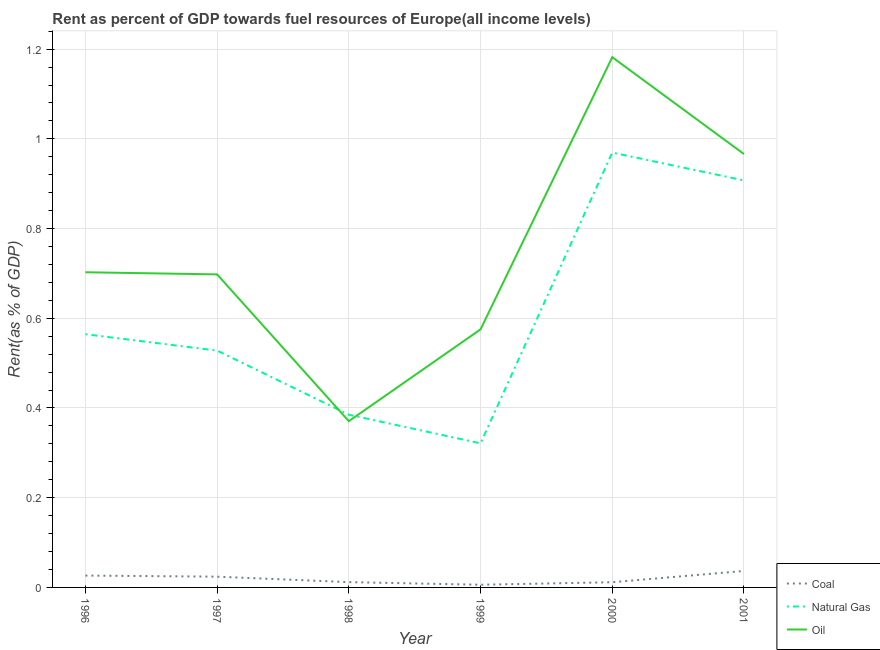Does the line corresponding to rent towards oil intersect with the line corresponding to rent towards natural gas?
Your answer should be compact. Yes. Is the number of lines equal to the number of legend labels?
Offer a very short reply. Yes. What is the rent towards natural gas in 1997?
Provide a short and direct response. 0.53. Across all years, what is the maximum rent towards coal?
Your answer should be very brief. 0.04. Across all years, what is the minimum rent towards coal?
Ensure brevity in your answer.  0.01. In which year was the rent towards natural gas minimum?
Your answer should be compact. 1999. What is the total rent towards oil in the graph?
Make the answer very short. 4.49. What is the difference between the rent towards oil in 1998 and that in 2000?
Your answer should be compact. -0.81. What is the difference between the rent towards oil in 1997 and the rent towards natural gas in 1998?
Provide a short and direct response. 0.31. What is the average rent towards oil per year?
Your answer should be compact. 0.75. In the year 2001, what is the difference between the rent towards oil and rent towards natural gas?
Give a very brief answer. 0.06. What is the ratio of the rent towards oil in 1999 to that in 2001?
Ensure brevity in your answer.  0.6. What is the difference between the highest and the second highest rent towards natural gas?
Offer a very short reply. 0.06. What is the difference between the highest and the lowest rent towards coal?
Give a very brief answer. 0.03. In how many years, is the rent towards coal greater than the average rent towards coal taken over all years?
Give a very brief answer. 3. Is the sum of the rent towards natural gas in 1999 and 2001 greater than the maximum rent towards oil across all years?
Your answer should be very brief. Yes. Is it the case that in every year, the sum of the rent towards coal and rent towards natural gas is greater than the rent towards oil?
Offer a very short reply. No. Does the rent towards natural gas monotonically increase over the years?
Keep it short and to the point. No. Is the rent towards natural gas strictly less than the rent towards oil over the years?
Your answer should be compact. No. How many years are there in the graph?
Keep it short and to the point. 6. What is the difference between two consecutive major ticks on the Y-axis?
Offer a terse response. 0.2. Does the graph contain grids?
Your answer should be very brief. Yes. How many legend labels are there?
Provide a succinct answer. 3. What is the title of the graph?
Provide a succinct answer. Rent as percent of GDP towards fuel resources of Europe(all income levels). Does "Industry" appear as one of the legend labels in the graph?
Offer a very short reply. No. What is the label or title of the X-axis?
Provide a succinct answer. Year. What is the label or title of the Y-axis?
Provide a succinct answer. Rent(as % of GDP). What is the Rent(as % of GDP) in Coal in 1996?
Your answer should be very brief. 0.03. What is the Rent(as % of GDP) of Natural Gas in 1996?
Give a very brief answer. 0.56. What is the Rent(as % of GDP) in Oil in 1996?
Give a very brief answer. 0.7. What is the Rent(as % of GDP) in Coal in 1997?
Keep it short and to the point. 0.02. What is the Rent(as % of GDP) of Natural Gas in 1997?
Give a very brief answer. 0.53. What is the Rent(as % of GDP) in Oil in 1997?
Keep it short and to the point. 0.7. What is the Rent(as % of GDP) of Coal in 1998?
Offer a very short reply. 0.01. What is the Rent(as % of GDP) in Natural Gas in 1998?
Offer a very short reply. 0.38. What is the Rent(as % of GDP) in Oil in 1998?
Ensure brevity in your answer.  0.37. What is the Rent(as % of GDP) in Coal in 1999?
Provide a succinct answer. 0.01. What is the Rent(as % of GDP) in Natural Gas in 1999?
Your answer should be compact. 0.32. What is the Rent(as % of GDP) in Oil in 1999?
Provide a succinct answer. 0.58. What is the Rent(as % of GDP) in Coal in 2000?
Provide a succinct answer. 0.01. What is the Rent(as % of GDP) in Natural Gas in 2000?
Your response must be concise. 0.97. What is the Rent(as % of GDP) in Oil in 2000?
Keep it short and to the point. 1.18. What is the Rent(as % of GDP) in Coal in 2001?
Your response must be concise. 0.04. What is the Rent(as % of GDP) in Natural Gas in 2001?
Offer a terse response. 0.91. What is the Rent(as % of GDP) in Oil in 2001?
Keep it short and to the point. 0.97. Across all years, what is the maximum Rent(as % of GDP) of Coal?
Keep it short and to the point. 0.04. Across all years, what is the maximum Rent(as % of GDP) in Natural Gas?
Offer a very short reply. 0.97. Across all years, what is the maximum Rent(as % of GDP) in Oil?
Your answer should be very brief. 1.18. Across all years, what is the minimum Rent(as % of GDP) in Coal?
Provide a short and direct response. 0.01. Across all years, what is the minimum Rent(as % of GDP) in Natural Gas?
Make the answer very short. 0.32. Across all years, what is the minimum Rent(as % of GDP) of Oil?
Offer a terse response. 0.37. What is the total Rent(as % of GDP) of Coal in the graph?
Your answer should be compact. 0.12. What is the total Rent(as % of GDP) of Natural Gas in the graph?
Offer a very short reply. 3.68. What is the total Rent(as % of GDP) in Oil in the graph?
Provide a succinct answer. 4.49. What is the difference between the Rent(as % of GDP) in Coal in 1996 and that in 1997?
Ensure brevity in your answer.  0. What is the difference between the Rent(as % of GDP) in Natural Gas in 1996 and that in 1997?
Ensure brevity in your answer.  0.04. What is the difference between the Rent(as % of GDP) in Oil in 1996 and that in 1997?
Provide a short and direct response. 0. What is the difference between the Rent(as % of GDP) in Coal in 1996 and that in 1998?
Keep it short and to the point. 0.01. What is the difference between the Rent(as % of GDP) of Natural Gas in 1996 and that in 1998?
Offer a very short reply. 0.18. What is the difference between the Rent(as % of GDP) in Oil in 1996 and that in 1998?
Provide a short and direct response. 0.33. What is the difference between the Rent(as % of GDP) in Coal in 1996 and that in 1999?
Make the answer very short. 0.02. What is the difference between the Rent(as % of GDP) of Natural Gas in 1996 and that in 1999?
Make the answer very short. 0.24. What is the difference between the Rent(as % of GDP) of Oil in 1996 and that in 1999?
Provide a short and direct response. 0.13. What is the difference between the Rent(as % of GDP) in Coal in 1996 and that in 2000?
Ensure brevity in your answer.  0.01. What is the difference between the Rent(as % of GDP) in Natural Gas in 1996 and that in 2000?
Keep it short and to the point. -0.4. What is the difference between the Rent(as % of GDP) of Oil in 1996 and that in 2000?
Give a very brief answer. -0.48. What is the difference between the Rent(as % of GDP) of Coal in 1996 and that in 2001?
Offer a terse response. -0.01. What is the difference between the Rent(as % of GDP) of Natural Gas in 1996 and that in 2001?
Give a very brief answer. -0.34. What is the difference between the Rent(as % of GDP) of Oil in 1996 and that in 2001?
Your answer should be compact. -0.26. What is the difference between the Rent(as % of GDP) in Coal in 1997 and that in 1998?
Your answer should be very brief. 0.01. What is the difference between the Rent(as % of GDP) in Natural Gas in 1997 and that in 1998?
Keep it short and to the point. 0.14. What is the difference between the Rent(as % of GDP) of Oil in 1997 and that in 1998?
Your answer should be compact. 0.33. What is the difference between the Rent(as % of GDP) in Coal in 1997 and that in 1999?
Provide a succinct answer. 0.02. What is the difference between the Rent(as % of GDP) of Natural Gas in 1997 and that in 1999?
Offer a very short reply. 0.21. What is the difference between the Rent(as % of GDP) in Oil in 1997 and that in 1999?
Ensure brevity in your answer.  0.12. What is the difference between the Rent(as % of GDP) of Coal in 1997 and that in 2000?
Offer a very short reply. 0.01. What is the difference between the Rent(as % of GDP) in Natural Gas in 1997 and that in 2000?
Ensure brevity in your answer.  -0.44. What is the difference between the Rent(as % of GDP) in Oil in 1997 and that in 2000?
Your answer should be compact. -0.48. What is the difference between the Rent(as % of GDP) of Coal in 1997 and that in 2001?
Offer a very short reply. -0.01. What is the difference between the Rent(as % of GDP) of Natural Gas in 1997 and that in 2001?
Provide a succinct answer. -0.38. What is the difference between the Rent(as % of GDP) in Oil in 1997 and that in 2001?
Offer a very short reply. -0.27. What is the difference between the Rent(as % of GDP) in Coal in 1998 and that in 1999?
Offer a very short reply. 0.01. What is the difference between the Rent(as % of GDP) of Natural Gas in 1998 and that in 1999?
Your answer should be compact. 0.06. What is the difference between the Rent(as % of GDP) of Oil in 1998 and that in 1999?
Make the answer very short. -0.2. What is the difference between the Rent(as % of GDP) of Coal in 1998 and that in 2000?
Offer a terse response. 0. What is the difference between the Rent(as % of GDP) of Natural Gas in 1998 and that in 2000?
Ensure brevity in your answer.  -0.58. What is the difference between the Rent(as % of GDP) in Oil in 1998 and that in 2000?
Give a very brief answer. -0.81. What is the difference between the Rent(as % of GDP) in Coal in 1998 and that in 2001?
Ensure brevity in your answer.  -0.02. What is the difference between the Rent(as % of GDP) in Natural Gas in 1998 and that in 2001?
Give a very brief answer. -0.52. What is the difference between the Rent(as % of GDP) of Oil in 1998 and that in 2001?
Your answer should be compact. -0.6. What is the difference between the Rent(as % of GDP) of Coal in 1999 and that in 2000?
Provide a succinct answer. -0.01. What is the difference between the Rent(as % of GDP) of Natural Gas in 1999 and that in 2000?
Your response must be concise. -0.65. What is the difference between the Rent(as % of GDP) in Oil in 1999 and that in 2000?
Your answer should be compact. -0.61. What is the difference between the Rent(as % of GDP) in Coal in 1999 and that in 2001?
Offer a very short reply. -0.03. What is the difference between the Rent(as % of GDP) of Natural Gas in 1999 and that in 2001?
Ensure brevity in your answer.  -0.59. What is the difference between the Rent(as % of GDP) in Oil in 1999 and that in 2001?
Ensure brevity in your answer.  -0.39. What is the difference between the Rent(as % of GDP) of Coal in 2000 and that in 2001?
Your response must be concise. -0.03. What is the difference between the Rent(as % of GDP) of Natural Gas in 2000 and that in 2001?
Your answer should be compact. 0.06. What is the difference between the Rent(as % of GDP) of Oil in 2000 and that in 2001?
Your answer should be very brief. 0.22. What is the difference between the Rent(as % of GDP) of Coal in 1996 and the Rent(as % of GDP) of Natural Gas in 1997?
Offer a terse response. -0.5. What is the difference between the Rent(as % of GDP) of Coal in 1996 and the Rent(as % of GDP) of Oil in 1997?
Your answer should be very brief. -0.67. What is the difference between the Rent(as % of GDP) of Natural Gas in 1996 and the Rent(as % of GDP) of Oil in 1997?
Make the answer very short. -0.13. What is the difference between the Rent(as % of GDP) of Coal in 1996 and the Rent(as % of GDP) of Natural Gas in 1998?
Provide a succinct answer. -0.36. What is the difference between the Rent(as % of GDP) in Coal in 1996 and the Rent(as % of GDP) in Oil in 1998?
Make the answer very short. -0.34. What is the difference between the Rent(as % of GDP) in Natural Gas in 1996 and the Rent(as % of GDP) in Oil in 1998?
Make the answer very short. 0.19. What is the difference between the Rent(as % of GDP) in Coal in 1996 and the Rent(as % of GDP) in Natural Gas in 1999?
Your answer should be compact. -0.29. What is the difference between the Rent(as % of GDP) of Coal in 1996 and the Rent(as % of GDP) of Oil in 1999?
Give a very brief answer. -0.55. What is the difference between the Rent(as % of GDP) in Natural Gas in 1996 and the Rent(as % of GDP) in Oil in 1999?
Make the answer very short. -0.01. What is the difference between the Rent(as % of GDP) of Coal in 1996 and the Rent(as % of GDP) of Natural Gas in 2000?
Make the answer very short. -0.94. What is the difference between the Rent(as % of GDP) in Coal in 1996 and the Rent(as % of GDP) in Oil in 2000?
Provide a short and direct response. -1.16. What is the difference between the Rent(as % of GDP) of Natural Gas in 1996 and the Rent(as % of GDP) of Oil in 2000?
Offer a terse response. -0.62. What is the difference between the Rent(as % of GDP) in Coal in 1996 and the Rent(as % of GDP) in Natural Gas in 2001?
Ensure brevity in your answer.  -0.88. What is the difference between the Rent(as % of GDP) in Coal in 1996 and the Rent(as % of GDP) in Oil in 2001?
Offer a terse response. -0.94. What is the difference between the Rent(as % of GDP) in Natural Gas in 1996 and the Rent(as % of GDP) in Oil in 2001?
Make the answer very short. -0.4. What is the difference between the Rent(as % of GDP) in Coal in 1997 and the Rent(as % of GDP) in Natural Gas in 1998?
Your answer should be compact. -0.36. What is the difference between the Rent(as % of GDP) in Coal in 1997 and the Rent(as % of GDP) in Oil in 1998?
Offer a very short reply. -0.35. What is the difference between the Rent(as % of GDP) in Natural Gas in 1997 and the Rent(as % of GDP) in Oil in 1998?
Keep it short and to the point. 0.16. What is the difference between the Rent(as % of GDP) in Coal in 1997 and the Rent(as % of GDP) in Natural Gas in 1999?
Your answer should be compact. -0.3. What is the difference between the Rent(as % of GDP) of Coal in 1997 and the Rent(as % of GDP) of Oil in 1999?
Your answer should be compact. -0.55. What is the difference between the Rent(as % of GDP) in Natural Gas in 1997 and the Rent(as % of GDP) in Oil in 1999?
Give a very brief answer. -0.05. What is the difference between the Rent(as % of GDP) of Coal in 1997 and the Rent(as % of GDP) of Natural Gas in 2000?
Your response must be concise. -0.95. What is the difference between the Rent(as % of GDP) of Coal in 1997 and the Rent(as % of GDP) of Oil in 2000?
Your answer should be compact. -1.16. What is the difference between the Rent(as % of GDP) of Natural Gas in 1997 and the Rent(as % of GDP) of Oil in 2000?
Your answer should be very brief. -0.65. What is the difference between the Rent(as % of GDP) of Coal in 1997 and the Rent(as % of GDP) of Natural Gas in 2001?
Provide a succinct answer. -0.88. What is the difference between the Rent(as % of GDP) in Coal in 1997 and the Rent(as % of GDP) in Oil in 2001?
Give a very brief answer. -0.94. What is the difference between the Rent(as % of GDP) of Natural Gas in 1997 and the Rent(as % of GDP) of Oil in 2001?
Your answer should be very brief. -0.44. What is the difference between the Rent(as % of GDP) of Coal in 1998 and the Rent(as % of GDP) of Natural Gas in 1999?
Your response must be concise. -0.31. What is the difference between the Rent(as % of GDP) of Coal in 1998 and the Rent(as % of GDP) of Oil in 1999?
Offer a terse response. -0.56. What is the difference between the Rent(as % of GDP) in Natural Gas in 1998 and the Rent(as % of GDP) in Oil in 1999?
Provide a short and direct response. -0.19. What is the difference between the Rent(as % of GDP) in Coal in 1998 and the Rent(as % of GDP) in Natural Gas in 2000?
Offer a very short reply. -0.96. What is the difference between the Rent(as % of GDP) in Coal in 1998 and the Rent(as % of GDP) in Oil in 2000?
Ensure brevity in your answer.  -1.17. What is the difference between the Rent(as % of GDP) of Natural Gas in 1998 and the Rent(as % of GDP) of Oil in 2000?
Ensure brevity in your answer.  -0.8. What is the difference between the Rent(as % of GDP) of Coal in 1998 and the Rent(as % of GDP) of Natural Gas in 2001?
Make the answer very short. -0.9. What is the difference between the Rent(as % of GDP) in Coal in 1998 and the Rent(as % of GDP) in Oil in 2001?
Your answer should be very brief. -0.95. What is the difference between the Rent(as % of GDP) in Natural Gas in 1998 and the Rent(as % of GDP) in Oil in 2001?
Provide a short and direct response. -0.58. What is the difference between the Rent(as % of GDP) in Coal in 1999 and the Rent(as % of GDP) in Natural Gas in 2000?
Provide a short and direct response. -0.96. What is the difference between the Rent(as % of GDP) of Coal in 1999 and the Rent(as % of GDP) of Oil in 2000?
Provide a short and direct response. -1.18. What is the difference between the Rent(as % of GDP) of Natural Gas in 1999 and the Rent(as % of GDP) of Oil in 2000?
Give a very brief answer. -0.86. What is the difference between the Rent(as % of GDP) of Coal in 1999 and the Rent(as % of GDP) of Natural Gas in 2001?
Offer a terse response. -0.9. What is the difference between the Rent(as % of GDP) in Coal in 1999 and the Rent(as % of GDP) in Oil in 2001?
Make the answer very short. -0.96. What is the difference between the Rent(as % of GDP) of Natural Gas in 1999 and the Rent(as % of GDP) of Oil in 2001?
Keep it short and to the point. -0.64. What is the difference between the Rent(as % of GDP) in Coal in 2000 and the Rent(as % of GDP) in Natural Gas in 2001?
Your answer should be compact. -0.9. What is the difference between the Rent(as % of GDP) of Coal in 2000 and the Rent(as % of GDP) of Oil in 2001?
Your answer should be very brief. -0.95. What is the difference between the Rent(as % of GDP) in Natural Gas in 2000 and the Rent(as % of GDP) in Oil in 2001?
Provide a short and direct response. 0. What is the average Rent(as % of GDP) in Coal per year?
Offer a terse response. 0.02. What is the average Rent(as % of GDP) of Natural Gas per year?
Offer a terse response. 0.61. What is the average Rent(as % of GDP) in Oil per year?
Your response must be concise. 0.75. In the year 1996, what is the difference between the Rent(as % of GDP) in Coal and Rent(as % of GDP) in Natural Gas?
Offer a very short reply. -0.54. In the year 1996, what is the difference between the Rent(as % of GDP) of Coal and Rent(as % of GDP) of Oil?
Make the answer very short. -0.68. In the year 1996, what is the difference between the Rent(as % of GDP) of Natural Gas and Rent(as % of GDP) of Oil?
Your answer should be compact. -0.14. In the year 1997, what is the difference between the Rent(as % of GDP) of Coal and Rent(as % of GDP) of Natural Gas?
Make the answer very short. -0.5. In the year 1997, what is the difference between the Rent(as % of GDP) of Coal and Rent(as % of GDP) of Oil?
Provide a short and direct response. -0.67. In the year 1997, what is the difference between the Rent(as % of GDP) of Natural Gas and Rent(as % of GDP) of Oil?
Provide a succinct answer. -0.17. In the year 1998, what is the difference between the Rent(as % of GDP) in Coal and Rent(as % of GDP) in Natural Gas?
Provide a short and direct response. -0.37. In the year 1998, what is the difference between the Rent(as % of GDP) of Coal and Rent(as % of GDP) of Oil?
Ensure brevity in your answer.  -0.36. In the year 1998, what is the difference between the Rent(as % of GDP) of Natural Gas and Rent(as % of GDP) of Oil?
Make the answer very short. 0.01. In the year 1999, what is the difference between the Rent(as % of GDP) of Coal and Rent(as % of GDP) of Natural Gas?
Give a very brief answer. -0.32. In the year 1999, what is the difference between the Rent(as % of GDP) of Coal and Rent(as % of GDP) of Oil?
Offer a terse response. -0.57. In the year 1999, what is the difference between the Rent(as % of GDP) in Natural Gas and Rent(as % of GDP) in Oil?
Ensure brevity in your answer.  -0.25. In the year 2000, what is the difference between the Rent(as % of GDP) of Coal and Rent(as % of GDP) of Natural Gas?
Give a very brief answer. -0.96. In the year 2000, what is the difference between the Rent(as % of GDP) of Coal and Rent(as % of GDP) of Oil?
Make the answer very short. -1.17. In the year 2000, what is the difference between the Rent(as % of GDP) in Natural Gas and Rent(as % of GDP) in Oil?
Offer a terse response. -0.21. In the year 2001, what is the difference between the Rent(as % of GDP) of Coal and Rent(as % of GDP) of Natural Gas?
Offer a terse response. -0.87. In the year 2001, what is the difference between the Rent(as % of GDP) in Coal and Rent(as % of GDP) in Oil?
Provide a short and direct response. -0.93. In the year 2001, what is the difference between the Rent(as % of GDP) in Natural Gas and Rent(as % of GDP) in Oil?
Give a very brief answer. -0.06. What is the ratio of the Rent(as % of GDP) of Coal in 1996 to that in 1997?
Give a very brief answer. 1.1. What is the ratio of the Rent(as % of GDP) in Natural Gas in 1996 to that in 1997?
Your answer should be very brief. 1.07. What is the ratio of the Rent(as % of GDP) in Oil in 1996 to that in 1997?
Offer a terse response. 1.01. What is the ratio of the Rent(as % of GDP) of Coal in 1996 to that in 1998?
Provide a succinct answer. 2.24. What is the ratio of the Rent(as % of GDP) in Natural Gas in 1996 to that in 1998?
Provide a succinct answer. 1.47. What is the ratio of the Rent(as % of GDP) of Oil in 1996 to that in 1998?
Provide a succinct answer. 1.9. What is the ratio of the Rent(as % of GDP) in Coal in 1996 to that in 1999?
Ensure brevity in your answer.  4.42. What is the ratio of the Rent(as % of GDP) of Natural Gas in 1996 to that in 1999?
Provide a short and direct response. 1.76. What is the ratio of the Rent(as % of GDP) of Oil in 1996 to that in 1999?
Ensure brevity in your answer.  1.22. What is the ratio of the Rent(as % of GDP) in Coal in 1996 to that in 2000?
Make the answer very short. 2.28. What is the ratio of the Rent(as % of GDP) in Natural Gas in 1996 to that in 2000?
Keep it short and to the point. 0.58. What is the ratio of the Rent(as % of GDP) in Oil in 1996 to that in 2000?
Your response must be concise. 0.59. What is the ratio of the Rent(as % of GDP) in Coal in 1996 to that in 2001?
Offer a very short reply. 0.72. What is the ratio of the Rent(as % of GDP) in Natural Gas in 1996 to that in 2001?
Your answer should be compact. 0.62. What is the ratio of the Rent(as % of GDP) of Oil in 1996 to that in 2001?
Your answer should be very brief. 0.73. What is the ratio of the Rent(as % of GDP) in Coal in 1997 to that in 1998?
Provide a short and direct response. 2.03. What is the ratio of the Rent(as % of GDP) in Natural Gas in 1997 to that in 1998?
Provide a succinct answer. 1.37. What is the ratio of the Rent(as % of GDP) in Oil in 1997 to that in 1998?
Your response must be concise. 1.88. What is the ratio of the Rent(as % of GDP) in Coal in 1997 to that in 1999?
Keep it short and to the point. 4.01. What is the ratio of the Rent(as % of GDP) of Natural Gas in 1997 to that in 1999?
Your answer should be very brief. 1.64. What is the ratio of the Rent(as % of GDP) of Oil in 1997 to that in 1999?
Provide a short and direct response. 1.21. What is the ratio of the Rent(as % of GDP) in Coal in 1997 to that in 2000?
Make the answer very short. 2.07. What is the ratio of the Rent(as % of GDP) in Natural Gas in 1997 to that in 2000?
Offer a terse response. 0.54. What is the ratio of the Rent(as % of GDP) of Oil in 1997 to that in 2000?
Make the answer very short. 0.59. What is the ratio of the Rent(as % of GDP) of Coal in 1997 to that in 2001?
Make the answer very short. 0.65. What is the ratio of the Rent(as % of GDP) in Natural Gas in 1997 to that in 2001?
Provide a short and direct response. 0.58. What is the ratio of the Rent(as % of GDP) of Oil in 1997 to that in 2001?
Provide a succinct answer. 0.72. What is the ratio of the Rent(as % of GDP) in Coal in 1998 to that in 1999?
Your response must be concise. 1.97. What is the ratio of the Rent(as % of GDP) of Natural Gas in 1998 to that in 1999?
Give a very brief answer. 1.2. What is the ratio of the Rent(as % of GDP) of Oil in 1998 to that in 1999?
Provide a short and direct response. 0.64. What is the ratio of the Rent(as % of GDP) in Coal in 1998 to that in 2000?
Keep it short and to the point. 1.02. What is the ratio of the Rent(as % of GDP) of Natural Gas in 1998 to that in 2000?
Offer a very short reply. 0.4. What is the ratio of the Rent(as % of GDP) of Oil in 1998 to that in 2000?
Provide a succinct answer. 0.31. What is the ratio of the Rent(as % of GDP) in Coal in 1998 to that in 2001?
Ensure brevity in your answer.  0.32. What is the ratio of the Rent(as % of GDP) of Natural Gas in 1998 to that in 2001?
Your answer should be very brief. 0.42. What is the ratio of the Rent(as % of GDP) of Oil in 1998 to that in 2001?
Your answer should be compact. 0.38. What is the ratio of the Rent(as % of GDP) of Coal in 1999 to that in 2000?
Your answer should be compact. 0.52. What is the ratio of the Rent(as % of GDP) of Natural Gas in 1999 to that in 2000?
Keep it short and to the point. 0.33. What is the ratio of the Rent(as % of GDP) of Oil in 1999 to that in 2000?
Your answer should be very brief. 0.49. What is the ratio of the Rent(as % of GDP) in Coal in 1999 to that in 2001?
Your answer should be compact. 0.16. What is the ratio of the Rent(as % of GDP) of Natural Gas in 1999 to that in 2001?
Give a very brief answer. 0.35. What is the ratio of the Rent(as % of GDP) in Oil in 1999 to that in 2001?
Your response must be concise. 0.6. What is the ratio of the Rent(as % of GDP) of Coal in 2000 to that in 2001?
Offer a terse response. 0.32. What is the ratio of the Rent(as % of GDP) in Natural Gas in 2000 to that in 2001?
Make the answer very short. 1.07. What is the ratio of the Rent(as % of GDP) in Oil in 2000 to that in 2001?
Offer a very short reply. 1.22. What is the difference between the highest and the second highest Rent(as % of GDP) of Coal?
Keep it short and to the point. 0.01. What is the difference between the highest and the second highest Rent(as % of GDP) of Natural Gas?
Offer a very short reply. 0.06. What is the difference between the highest and the second highest Rent(as % of GDP) in Oil?
Your response must be concise. 0.22. What is the difference between the highest and the lowest Rent(as % of GDP) in Coal?
Make the answer very short. 0.03. What is the difference between the highest and the lowest Rent(as % of GDP) in Natural Gas?
Your answer should be compact. 0.65. What is the difference between the highest and the lowest Rent(as % of GDP) of Oil?
Provide a short and direct response. 0.81. 